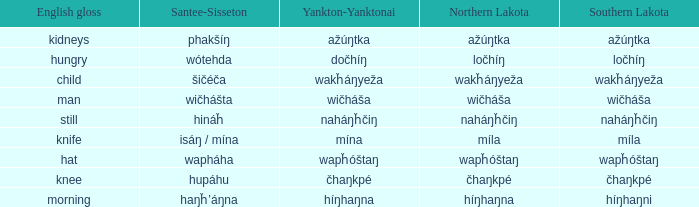Name the southern lakota for híŋhaŋna Híŋhaŋni. 